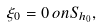Convert formula to latex. <formula><loc_0><loc_0><loc_500><loc_500>\xi _ { 0 } = 0 \, o n S _ { h _ { 0 } } ,</formula> 